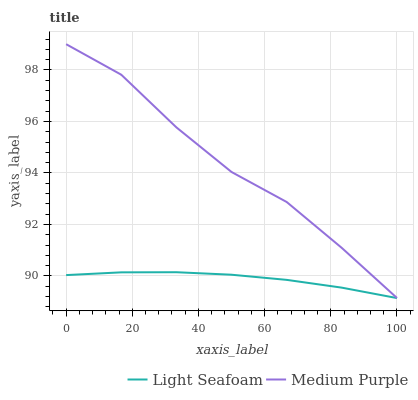Does Light Seafoam have the minimum area under the curve?
Answer yes or no. Yes. Does Medium Purple have the maximum area under the curve?
Answer yes or no. Yes. Does Light Seafoam have the maximum area under the curve?
Answer yes or no. No. Is Light Seafoam the smoothest?
Answer yes or no. Yes. Is Medium Purple the roughest?
Answer yes or no. Yes. Is Light Seafoam the roughest?
Answer yes or no. No. Does Light Seafoam have the lowest value?
Answer yes or no. Yes. Does Medium Purple have the highest value?
Answer yes or no. Yes. Does Light Seafoam have the highest value?
Answer yes or no. No. Is Light Seafoam less than Medium Purple?
Answer yes or no. Yes. Is Medium Purple greater than Light Seafoam?
Answer yes or no. Yes. Does Light Seafoam intersect Medium Purple?
Answer yes or no. No. 